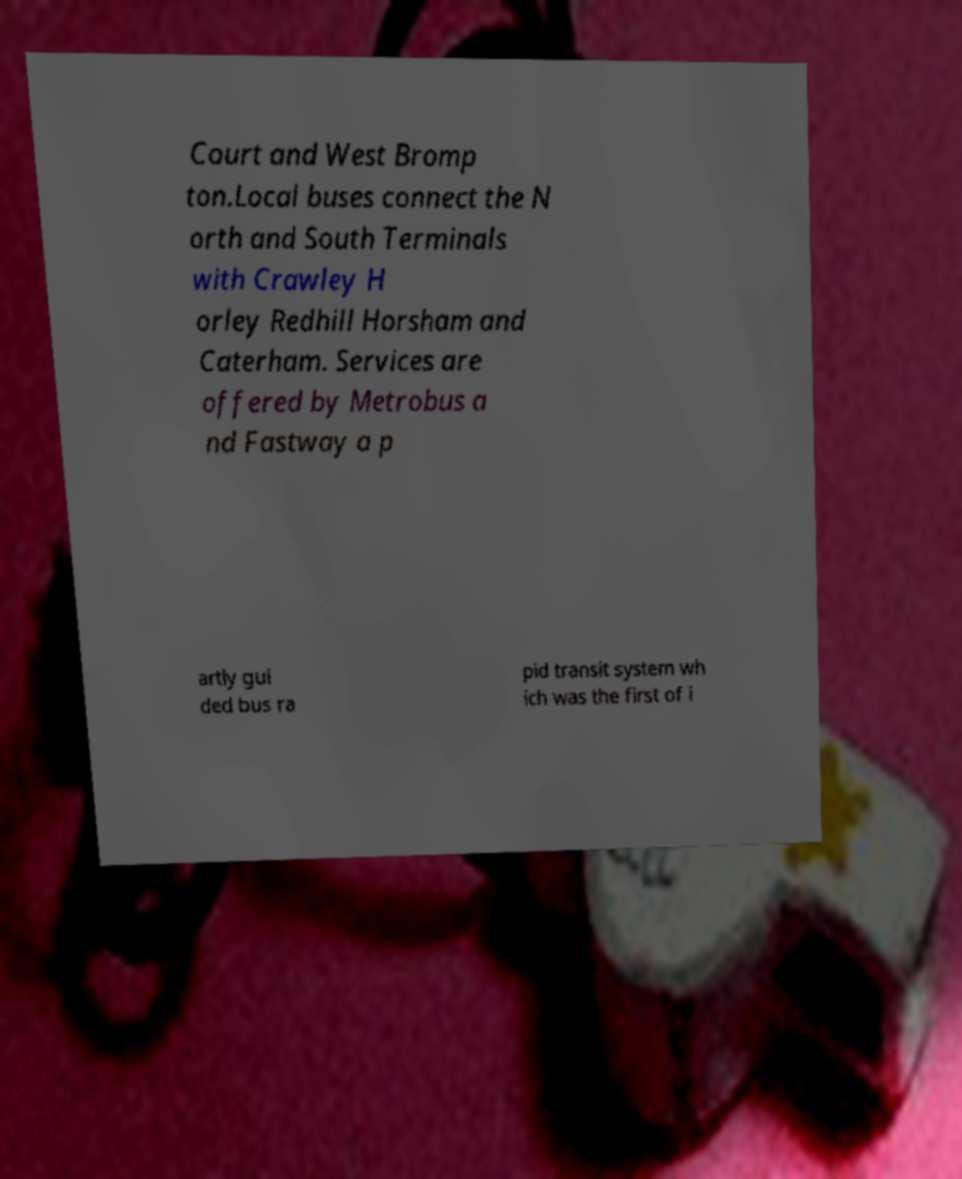Can you accurately transcribe the text from the provided image for me? Court and West Bromp ton.Local buses connect the N orth and South Terminals with Crawley H orley Redhill Horsham and Caterham. Services are offered by Metrobus a nd Fastway a p artly gui ded bus ra pid transit system wh ich was the first of i 